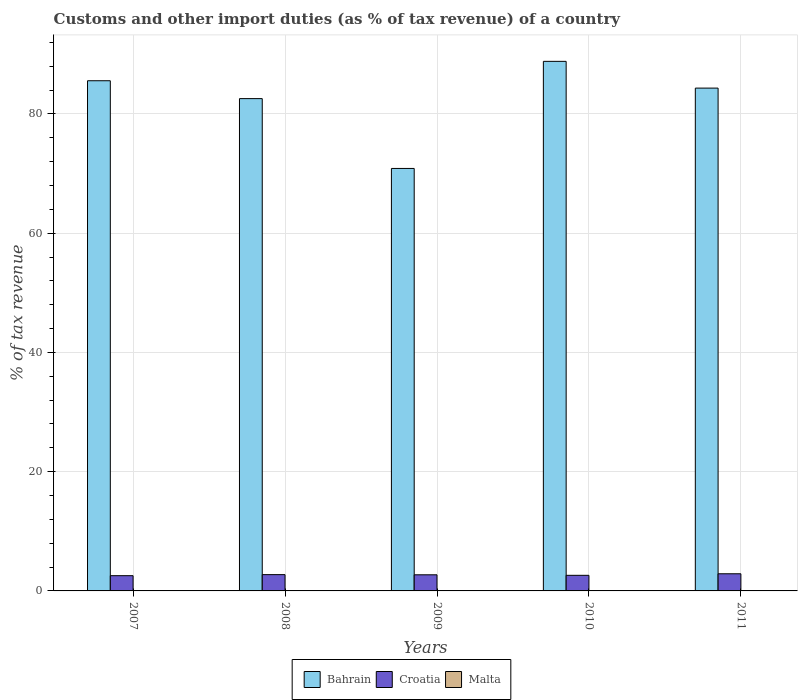How many different coloured bars are there?
Offer a terse response. 2. What is the label of the 4th group of bars from the left?
Provide a succinct answer. 2010. In how many cases, is the number of bars for a given year not equal to the number of legend labels?
Give a very brief answer. 5. Across all years, what is the maximum percentage of tax revenue from customs in Bahrain?
Your answer should be compact. 88.82. Across all years, what is the minimum percentage of tax revenue from customs in Croatia?
Your answer should be compact. 2.56. What is the total percentage of tax revenue from customs in Croatia in the graph?
Offer a very short reply. 13.48. What is the difference between the percentage of tax revenue from customs in Bahrain in 2008 and that in 2010?
Offer a very short reply. -6.25. What is the difference between the percentage of tax revenue from customs in Croatia in 2008 and the percentage of tax revenue from customs in Bahrain in 2010?
Provide a short and direct response. -86.09. What is the average percentage of tax revenue from customs in Croatia per year?
Keep it short and to the point. 2.7. In the year 2010, what is the difference between the percentage of tax revenue from customs in Croatia and percentage of tax revenue from customs in Bahrain?
Provide a short and direct response. -86.21. What is the ratio of the percentage of tax revenue from customs in Croatia in 2007 to that in 2011?
Offer a terse response. 0.89. Is the percentage of tax revenue from customs in Bahrain in 2008 less than that in 2009?
Offer a very short reply. No. What is the difference between the highest and the second highest percentage of tax revenue from customs in Croatia?
Your answer should be compact. 0.14. What is the difference between the highest and the lowest percentage of tax revenue from customs in Croatia?
Offer a very short reply. 0.32. In how many years, is the percentage of tax revenue from customs in Croatia greater than the average percentage of tax revenue from customs in Croatia taken over all years?
Provide a short and direct response. 3. How many years are there in the graph?
Your response must be concise. 5. What is the difference between two consecutive major ticks on the Y-axis?
Your response must be concise. 20. Where does the legend appear in the graph?
Your answer should be compact. Bottom center. How are the legend labels stacked?
Keep it short and to the point. Horizontal. What is the title of the graph?
Offer a terse response. Customs and other import duties (as % of tax revenue) of a country. What is the label or title of the Y-axis?
Your answer should be compact. % of tax revenue. What is the % of tax revenue of Bahrain in 2007?
Give a very brief answer. 85.57. What is the % of tax revenue in Croatia in 2007?
Keep it short and to the point. 2.56. What is the % of tax revenue in Malta in 2007?
Ensure brevity in your answer.  0. What is the % of tax revenue of Bahrain in 2008?
Give a very brief answer. 82.57. What is the % of tax revenue of Croatia in 2008?
Offer a terse response. 2.73. What is the % of tax revenue in Bahrain in 2009?
Make the answer very short. 70.86. What is the % of tax revenue in Croatia in 2009?
Your response must be concise. 2.7. What is the % of tax revenue in Bahrain in 2010?
Your answer should be compact. 88.82. What is the % of tax revenue of Croatia in 2010?
Provide a succinct answer. 2.62. What is the % of tax revenue of Malta in 2010?
Offer a terse response. 0. What is the % of tax revenue in Bahrain in 2011?
Give a very brief answer. 84.34. What is the % of tax revenue of Croatia in 2011?
Offer a very short reply. 2.88. What is the % of tax revenue of Malta in 2011?
Your response must be concise. 0. Across all years, what is the maximum % of tax revenue of Bahrain?
Your answer should be very brief. 88.82. Across all years, what is the maximum % of tax revenue of Croatia?
Provide a succinct answer. 2.88. Across all years, what is the minimum % of tax revenue in Bahrain?
Make the answer very short. 70.86. Across all years, what is the minimum % of tax revenue in Croatia?
Your answer should be very brief. 2.56. What is the total % of tax revenue of Bahrain in the graph?
Your answer should be very brief. 412.16. What is the total % of tax revenue of Croatia in the graph?
Make the answer very short. 13.48. What is the total % of tax revenue in Malta in the graph?
Your response must be concise. 0. What is the difference between the % of tax revenue of Bahrain in 2007 and that in 2008?
Provide a short and direct response. 3. What is the difference between the % of tax revenue of Croatia in 2007 and that in 2008?
Offer a very short reply. -0.18. What is the difference between the % of tax revenue in Bahrain in 2007 and that in 2009?
Your response must be concise. 14.71. What is the difference between the % of tax revenue in Croatia in 2007 and that in 2009?
Your answer should be very brief. -0.15. What is the difference between the % of tax revenue in Bahrain in 2007 and that in 2010?
Give a very brief answer. -3.25. What is the difference between the % of tax revenue of Croatia in 2007 and that in 2010?
Provide a succinct answer. -0.06. What is the difference between the % of tax revenue of Bahrain in 2007 and that in 2011?
Your response must be concise. 1.23. What is the difference between the % of tax revenue in Croatia in 2007 and that in 2011?
Provide a short and direct response. -0.32. What is the difference between the % of tax revenue of Bahrain in 2008 and that in 2009?
Ensure brevity in your answer.  11.71. What is the difference between the % of tax revenue of Croatia in 2008 and that in 2009?
Provide a short and direct response. 0.03. What is the difference between the % of tax revenue of Bahrain in 2008 and that in 2010?
Provide a succinct answer. -6.25. What is the difference between the % of tax revenue of Croatia in 2008 and that in 2010?
Offer a terse response. 0.12. What is the difference between the % of tax revenue in Bahrain in 2008 and that in 2011?
Provide a succinct answer. -1.76. What is the difference between the % of tax revenue of Croatia in 2008 and that in 2011?
Your answer should be compact. -0.14. What is the difference between the % of tax revenue in Bahrain in 2009 and that in 2010?
Offer a terse response. -17.96. What is the difference between the % of tax revenue in Croatia in 2009 and that in 2010?
Give a very brief answer. 0.09. What is the difference between the % of tax revenue in Bahrain in 2009 and that in 2011?
Provide a short and direct response. -13.48. What is the difference between the % of tax revenue in Croatia in 2009 and that in 2011?
Offer a very short reply. -0.17. What is the difference between the % of tax revenue of Bahrain in 2010 and that in 2011?
Offer a very short reply. 4.49. What is the difference between the % of tax revenue of Croatia in 2010 and that in 2011?
Your answer should be compact. -0.26. What is the difference between the % of tax revenue of Bahrain in 2007 and the % of tax revenue of Croatia in 2008?
Give a very brief answer. 82.84. What is the difference between the % of tax revenue in Bahrain in 2007 and the % of tax revenue in Croatia in 2009?
Give a very brief answer. 82.87. What is the difference between the % of tax revenue in Bahrain in 2007 and the % of tax revenue in Croatia in 2010?
Your answer should be compact. 82.95. What is the difference between the % of tax revenue of Bahrain in 2007 and the % of tax revenue of Croatia in 2011?
Provide a short and direct response. 82.69. What is the difference between the % of tax revenue of Bahrain in 2008 and the % of tax revenue of Croatia in 2009?
Provide a succinct answer. 79.87. What is the difference between the % of tax revenue in Bahrain in 2008 and the % of tax revenue in Croatia in 2010?
Provide a succinct answer. 79.96. What is the difference between the % of tax revenue of Bahrain in 2008 and the % of tax revenue of Croatia in 2011?
Provide a short and direct response. 79.7. What is the difference between the % of tax revenue of Bahrain in 2009 and the % of tax revenue of Croatia in 2010?
Provide a succinct answer. 68.24. What is the difference between the % of tax revenue in Bahrain in 2009 and the % of tax revenue in Croatia in 2011?
Ensure brevity in your answer.  67.98. What is the difference between the % of tax revenue of Bahrain in 2010 and the % of tax revenue of Croatia in 2011?
Offer a very short reply. 85.95. What is the average % of tax revenue of Bahrain per year?
Keep it short and to the point. 82.43. What is the average % of tax revenue in Croatia per year?
Make the answer very short. 2.7. In the year 2007, what is the difference between the % of tax revenue in Bahrain and % of tax revenue in Croatia?
Offer a terse response. 83.01. In the year 2008, what is the difference between the % of tax revenue in Bahrain and % of tax revenue in Croatia?
Provide a short and direct response. 79.84. In the year 2009, what is the difference between the % of tax revenue in Bahrain and % of tax revenue in Croatia?
Your answer should be very brief. 68.16. In the year 2010, what is the difference between the % of tax revenue of Bahrain and % of tax revenue of Croatia?
Your answer should be very brief. 86.21. In the year 2011, what is the difference between the % of tax revenue of Bahrain and % of tax revenue of Croatia?
Keep it short and to the point. 81.46. What is the ratio of the % of tax revenue in Bahrain in 2007 to that in 2008?
Your response must be concise. 1.04. What is the ratio of the % of tax revenue of Croatia in 2007 to that in 2008?
Ensure brevity in your answer.  0.94. What is the ratio of the % of tax revenue of Bahrain in 2007 to that in 2009?
Your answer should be very brief. 1.21. What is the ratio of the % of tax revenue in Croatia in 2007 to that in 2009?
Offer a very short reply. 0.95. What is the ratio of the % of tax revenue in Bahrain in 2007 to that in 2010?
Give a very brief answer. 0.96. What is the ratio of the % of tax revenue in Croatia in 2007 to that in 2010?
Your answer should be compact. 0.98. What is the ratio of the % of tax revenue in Bahrain in 2007 to that in 2011?
Make the answer very short. 1.01. What is the ratio of the % of tax revenue in Croatia in 2007 to that in 2011?
Make the answer very short. 0.89. What is the ratio of the % of tax revenue in Bahrain in 2008 to that in 2009?
Make the answer very short. 1.17. What is the ratio of the % of tax revenue of Croatia in 2008 to that in 2009?
Make the answer very short. 1.01. What is the ratio of the % of tax revenue in Bahrain in 2008 to that in 2010?
Offer a terse response. 0.93. What is the ratio of the % of tax revenue in Croatia in 2008 to that in 2010?
Make the answer very short. 1.04. What is the ratio of the % of tax revenue in Bahrain in 2008 to that in 2011?
Your response must be concise. 0.98. What is the ratio of the % of tax revenue in Croatia in 2008 to that in 2011?
Offer a very short reply. 0.95. What is the ratio of the % of tax revenue of Bahrain in 2009 to that in 2010?
Keep it short and to the point. 0.8. What is the ratio of the % of tax revenue of Croatia in 2009 to that in 2010?
Your response must be concise. 1.03. What is the ratio of the % of tax revenue in Bahrain in 2009 to that in 2011?
Your answer should be compact. 0.84. What is the ratio of the % of tax revenue in Croatia in 2009 to that in 2011?
Keep it short and to the point. 0.94. What is the ratio of the % of tax revenue of Bahrain in 2010 to that in 2011?
Your response must be concise. 1.05. What is the ratio of the % of tax revenue in Croatia in 2010 to that in 2011?
Make the answer very short. 0.91. What is the difference between the highest and the second highest % of tax revenue of Bahrain?
Ensure brevity in your answer.  3.25. What is the difference between the highest and the second highest % of tax revenue of Croatia?
Offer a very short reply. 0.14. What is the difference between the highest and the lowest % of tax revenue of Bahrain?
Ensure brevity in your answer.  17.96. What is the difference between the highest and the lowest % of tax revenue in Croatia?
Your response must be concise. 0.32. 